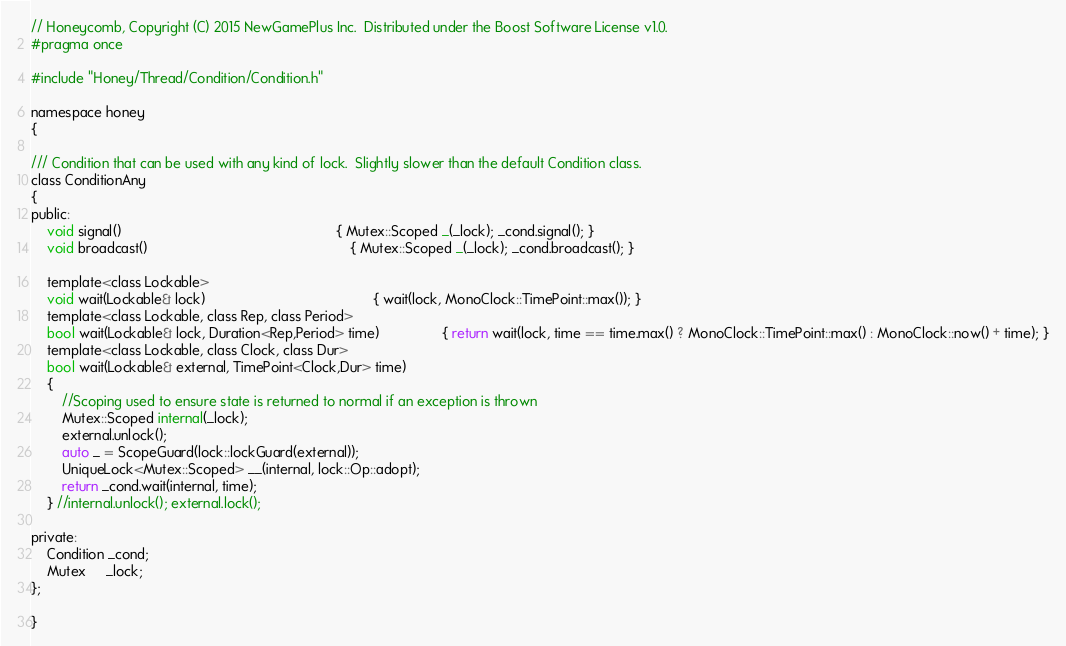<code> <loc_0><loc_0><loc_500><loc_500><_C_>// Honeycomb, Copyright (C) 2015 NewGamePlus Inc.  Distributed under the Boost Software License v1.0.
#pragma once

#include "Honey/Thread/Condition/Condition.h"

namespace honey
{

/// Condition that can be used with any kind of lock.  Slightly slower than the default Condition class.
class ConditionAny
{
public:
    void signal()                                                       { Mutex::Scoped _(_lock); _cond.signal(); }
    void broadcast()                                                    { Mutex::Scoped _(_lock); _cond.broadcast(); }

    template<class Lockable>
    void wait(Lockable& lock)                                           { wait(lock, MonoClock::TimePoint::max()); }
    template<class Lockable, class Rep, class Period>
    bool wait(Lockable& lock, Duration<Rep,Period> time)                { return wait(lock, time == time.max() ? MonoClock::TimePoint::max() : MonoClock::now() + time); }
    template<class Lockable, class Clock, class Dur>
    bool wait(Lockable& external, TimePoint<Clock,Dur> time)
    {
        //Scoping used to ensure state is returned to normal if an exception is thrown
        Mutex::Scoped internal(_lock);
        external.unlock();
        auto _ = ScopeGuard(lock::lockGuard(external));
        UniqueLock<Mutex::Scoped> __(internal, lock::Op::adopt);
        return _cond.wait(internal, time);
    } //internal.unlock(); external.lock();

private:
    Condition _cond;
    Mutex     _lock;
};

}
</code> 